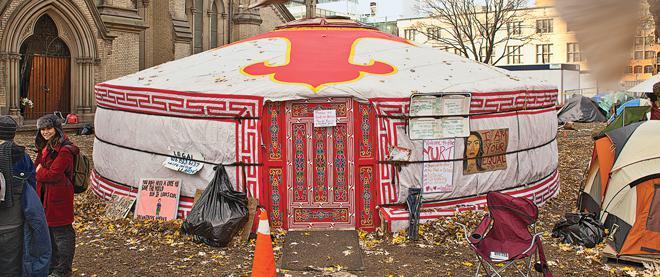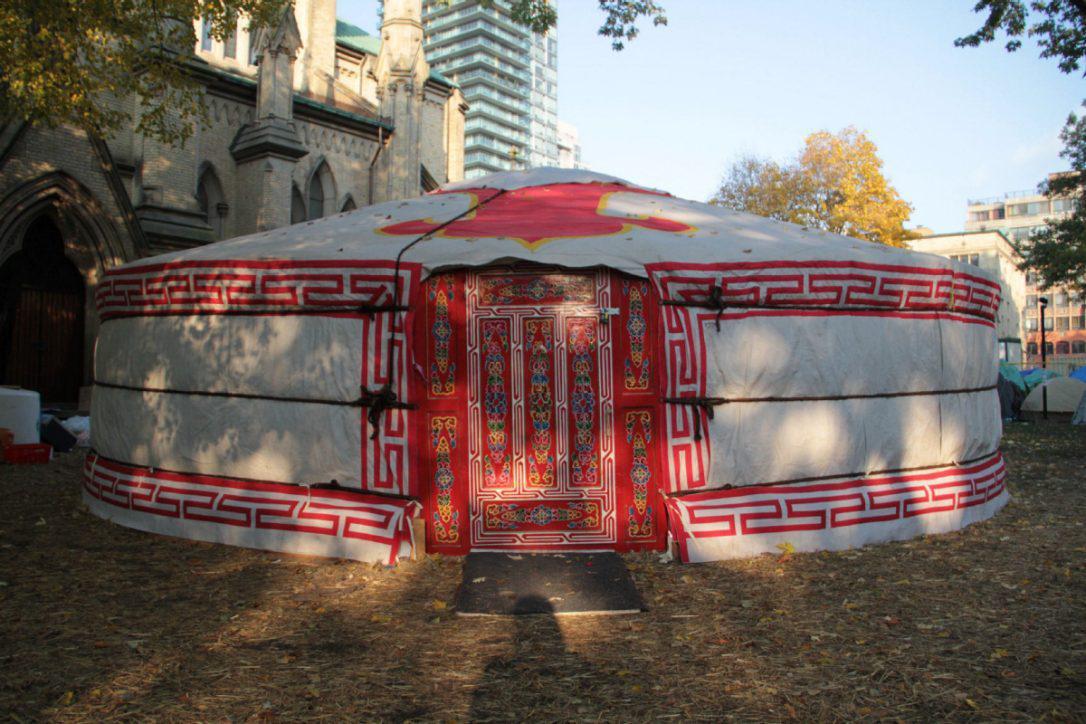The first image is the image on the left, the second image is the image on the right. For the images shown, is this caption "Exterior view of a tent with a red door." true? Answer yes or no. Yes. 